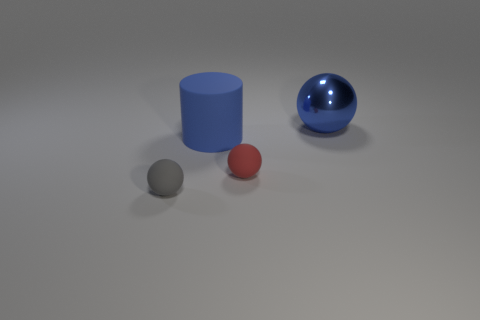Subtract all rubber balls. How many balls are left? 1 Add 1 gray matte objects. How many objects exist? 5 Subtract 1 spheres. How many spheres are left? 2 Subtract all spheres. How many objects are left? 1 Subtract all purple balls. Subtract all green blocks. How many balls are left? 3 Subtract all big blue rubber things. Subtract all tiny red matte balls. How many objects are left? 2 Add 2 blue rubber objects. How many blue rubber objects are left? 3 Add 3 gray rubber balls. How many gray rubber balls exist? 4 Subtract 0 purple spheres. How many objects are left? 4 